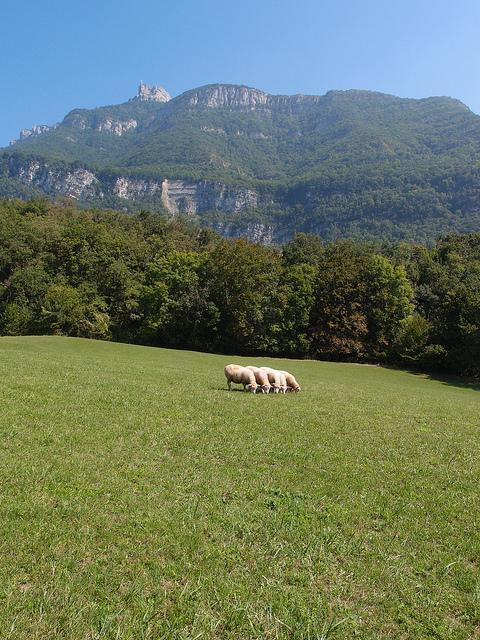How many farm animals?
Give a very brief answer. 5. 